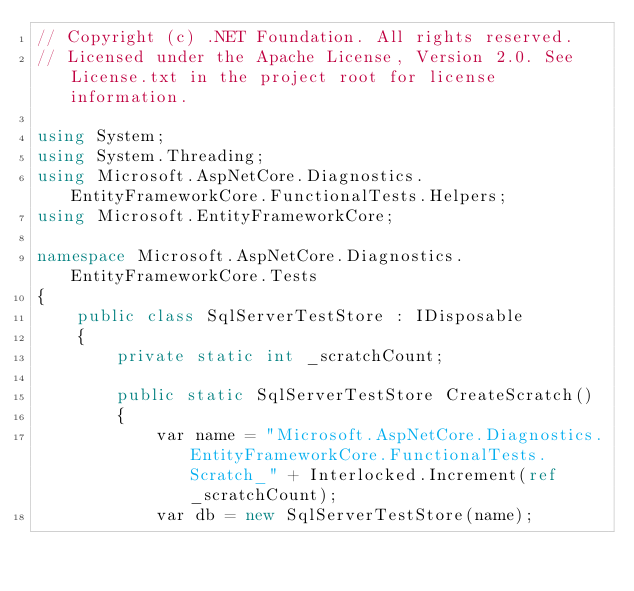Convert code to text. <code><loc_0><loc_0><loc_500><loc_500><_C#_>// Copyright (c) .NET Foundation. All rights reserved.
// Licensed under the Apache License, Version 2.0. See License.txt in the project root for license information.

using System;
using System.Threading;
using Microsoft.AspNetCore.Diagnostics.EntityFrameworkCore.FunctionalTests.Helpers;
using Microsoft.EntityFrameworkCore;

namespace Microsoft.AspNetCore.Diagnostics.EntityFrameworkCore.Tests
{
    public class SqlServerTestStore : IDisposable
    {
        private static int _scratchCount;

        public static SqlServerTestStore CreateScratch()
        {
            var name = "Microsoft.AspNetCore.Diagnostics.EntityFrameworkCore.FunctionalTests.Scratch_" + Interlocked.Increment(ref _scratchCount);
            var db = new SqlServerTestStore(name);</code> 